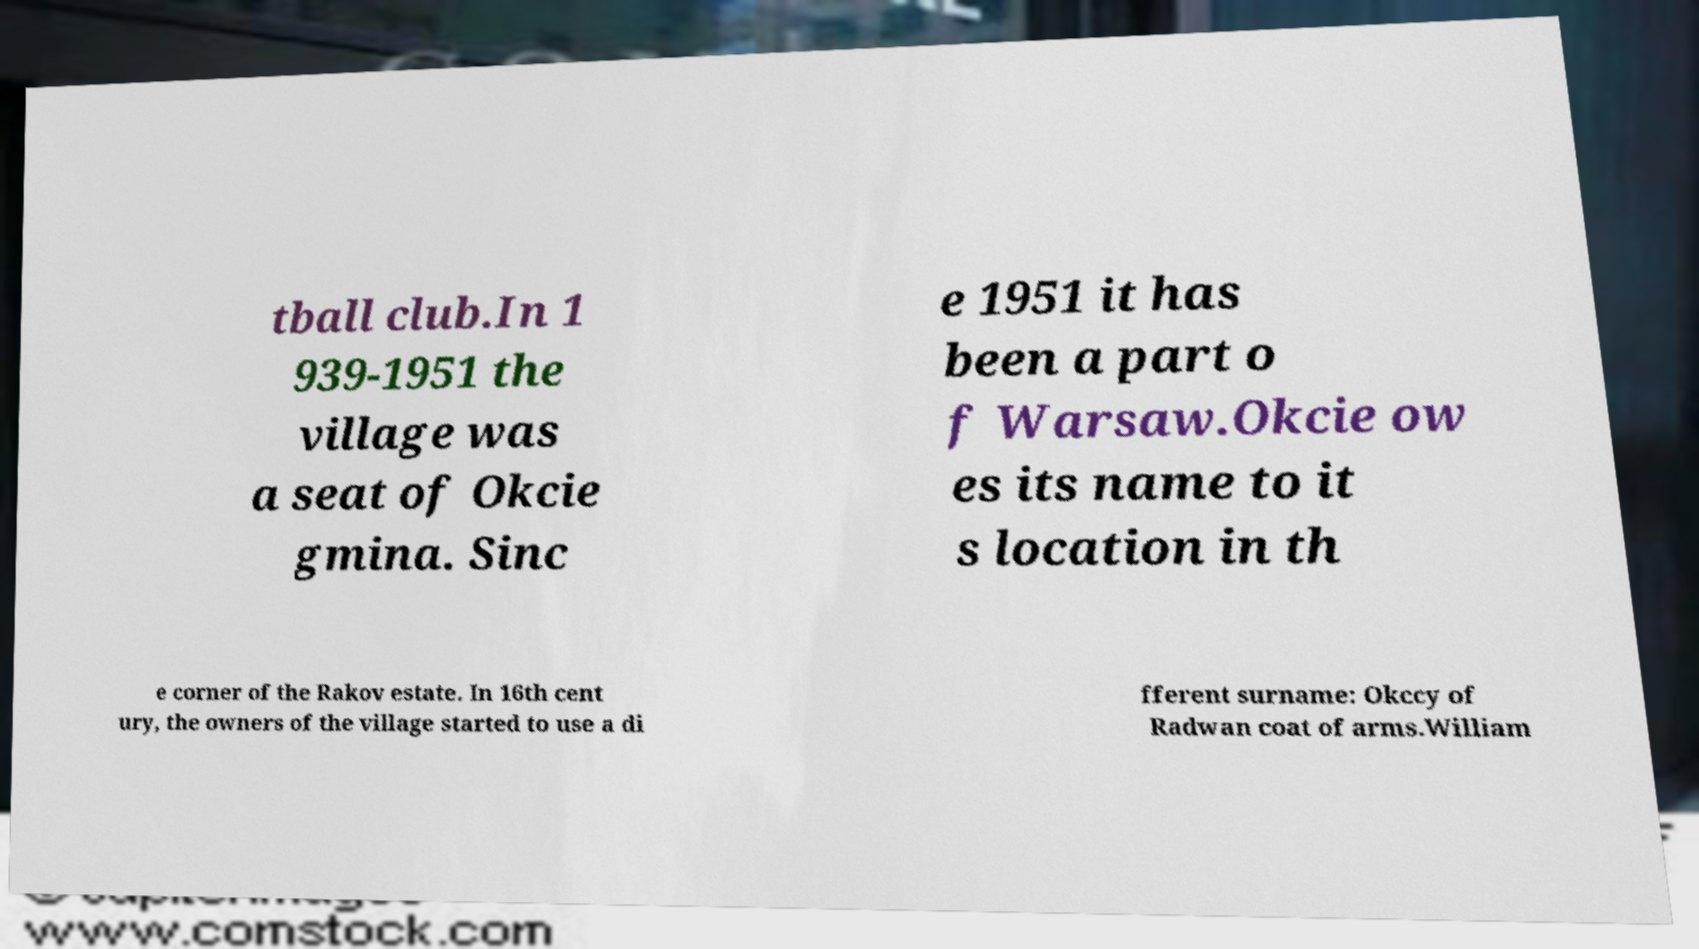I need the written content from this picture converted into text. Can you do that? tball club.In 1 939-1951 the village was a seat of Okcie gmina. Sinc e 1951 it has been a part o f Warsaw.Okcie ow es its name to it s location in th e corner of the Rakov estate. In 16th cent ury, the owners of the village started to use a di fferent surname: Okccy of Radwan coat of arms.William 